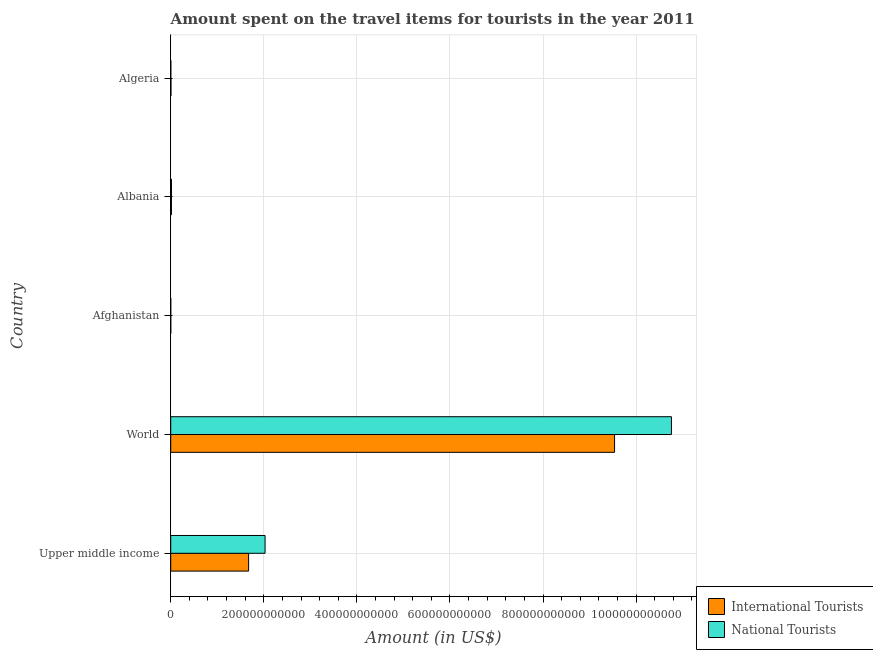How many different coloured bars are there?
Keep it short and to the point. 2. How many groups of bars are there?
Provide a short and direct response. 5. What is the label of the 3rd group of bars from the top?
Provide a succinct answer. Afghanistan. What is the amount spent on travel items of international tourists in Algeria?
Ensure brevity in your answer.  5.02e+08. Across all countries, what is the maximum amount spent on travel items of international tourists?
Provide a short and direct response. 9.54e+11. Across all countries, what is the minimum amount spent on travel items of international tourists?
Your answer should be compact. 1.13e+08. In which country was the amount spent on travel items of international tourists maximum?
Keep it short and to the point. World. In which country was the amount spent on travel items of international tourists minimum?
Give a very brief answer. Afghanistan. What is the total amount spent on travel items of national tourists in the graph?
Your response must be concise. 1.28e+12. What is the difference between the amount spent on travel items of national tourists in Upper middle income and that in World?
Your answer should be compact. -8.73e+11. What is the difference between the amount spent on travel items of international tourists in Upper middle income and the amount spent on travel items of national tourists in Afghanistan?
Make the answer very short. 1.67e+11. What is the average amount spent on travel items of national tourists per country?
Offer a terse response. 2.56e+11. What is the difference between the amount spent on travel items of national tourists and amount spent on travel items of international tourists in Afghanistan?
Offer a terse response. -4.20e+07. What is the ratio of the amount spent on travel items of national tourists in Upper middle income to that in World?
Provide a short and direct response. 0.19. What is the difference between the highest and the second highest amount spent on travel items of international tourists?
Make the answer very short. 7.86e+11. What is the difference between the highest and the lowest amount spent on travel items of national tourists?
Keep it short and to the point. 1.08e+12. Is the sum of the amount spent on travel items of national tourists in Afghanistan and World greater than the maximum amount spent on travel items of international tourists across all countries?
Provide a short and direct response. Yes. What does the 1st bar from the top in Albania represents?
Keep it short and to the point. National Tourists. What does the 1st bar from the bottom in Afghanistan represents?
Keep it short and to the point. International Tourists. How many bars are there?
Offer a very short reply. 10. What is the difference between two consecutive major ticks on the X-axis?
Offer a very short reply. 2.00e+11. Are the values on the major ticks of X-axis written in scientific E-notation?
Your answer should be compact. No. Does the graph contain grids?
Keep it short and to the point. Yes. How many legend labels are there?
Give a very brief answer. 2. How are the legend labels stacked?
Offer a very short reply. Vertical. What is the title of the graph?
Offer a very short reply. Amount spent on the travel items for tourists in the year 2011. What is the label or title of the Y-axis?
Provide a short and direct response. Country. What is the Amount (in US$) of International Tourists in Upper middle income?
Your response must be concise. 1.67e+11. What is the Amount (in US$) in National Tourists in Upper middle income?
Offer a terse response. 2.03e+11. What is the Amount (in US$) in International Tourists in World?
Make the answer very short. 9.54e+11. What is the Amount (in US$) of National Tourists in World?
Provide a succinct answer. 1.08e+12. What is the Amount (in US$) of International Tourists in Afghanistan?
Your response must be concise. 1.13e+08. What is the Amount (in US$) in National Tourists in Afghanistan?
Keep it short and to the point. 7.10e+07. What is the Amount (in US$) in International Tourists in Albania?
Make the answer very short. 1.56e+09. What is the Amount (in US$) of National Tourists in Albania?
Give a very brief answer. 1.63e+09. What is the Amount (in US$) of International Tourists in Algeria?
Offer a very short reply. 5.02e+08. What is the Amount (in US$) in National Tourists in Algeria?
Offer a very short reply. 2.09e+08. Across all countries, what is the maximum Amount (in US$) in International Tourists?
Make the answer very short. 9.54e+11. Across all countries, what is the maximum Amount (in US$) of National Tourists?
Your response must be concise. 1.08e+12. Across all countries, what is the minimum Amount (in US$) of International Tourists?
Offer a very short reply. 1.13e+08. Across all countries, what is the minimum Amount (in US$) of National Tourists?
Provide a succinct answer. 7.10e+07. What is the total Amount (in US$) in International Tourists in the graph?
Your response must be concise. 1.12e+12. What is the total Amount (in US$) of National Tourists in the graph?
Make the answer very short. 1.28e+12. What is the difference between the Amount (in US$) of International Tourists in Upper middle income and that in World?
Offer a terse response. -7.86e+11. What is the difference between the Amount (in US$) in National Tourists in Upper middle income and that in World?
Provide a succinct answer. -8.73e+11. What is the difference between the Amount (in US$) in International Tourists in Upper middle income and that in Afghanistan?
Offer a terse response. 1.67e+11. What is the difference between the Amount (in US$) in National Tourists in Upper middle income and that in Afghanistan?
Your answer should be compact. 2.03e+11. What is the difference between the Amount (in US$) of International Tourists in Upper middle income and that in Albania?
Your answer should be very brief. 1.66e+11. What is the difference between the Amount (in US$) in National Tourists in Upper middle income and that in Albania?
Your answer should be compact. 2.01e+11. What is the difference between the Amount (in US$) in International Tourists in Upper middle income and that in Algeria?
Offer a very short reply. 1.67e+11. What is the difference between the Amount (in US$) in National Tourists in Upper middle income and that in Algeria?
Make the answer very short. 2.03e+11. What is the difference between the Amount (in US$) of International Tourists in World and that in Afghanistan?
Your answer should be compact. 9.54e+11. What is the difference between the Amount (in US$) of National Tourists in World and that in Afghanistan?
Keep it short and to the point. 1.08e+12. What is the difference between the Amount (in US$) of International Tourists in World and that in Albania?
Offer a terse response. 9.52e+11. What is the difference between the Amount (in US$) of National Tourists in World and that in Albania?
Provide a succinct answer. 1.07e+12. What is the difference between the Amount (in US$) of International Tourists in World and that in Algeria?
Provide a short and direct response. 9.53e+11. What is the difference between the Amount (in US$) of National Tourists in World and that in Algeria?
Your answer should be compact. 1.08e+12. What is the difference between the Amount (in US$) of International Tourists in Afghanistan and that in Albania?
Offer a terse response. -1.45e+09. What is the difference between the Amount (in US$) in National Tourists in Afghanistan and that in Albania?
Your response must be concise. -1.56e+09. What is the difference between the Amount (in US$) in International Tourists in Afghanistan and that in Algeria?
Provide a short and direct response. -3.89e+08. What is the difference between the Amount (in US$) in National Tourists in Afghanistan and that in Algeria?
Offer a very short reply. -1.38e+08. What is the difference between the Amount (in US$) of International Tourists in Albania and that in Algeria?
Give a very brief answer. 1.06e+09. What is the difference between the Amount (in US$) of National Tourists in Albania and that in Algeria?
Your answer should be compact. 1.42e+09. What is the difference between the Amount (in US$) in International Tourists in Upper middle income and the Amount (in US$) in National Tourists in World?
Ensure brevity in your answer.  -9.08e+11. What is the difference between the Amount (in US$) in International Tourists in Upper middle income and the Amount (in US$) in National Tourists in Afghanistan?
Your answer should be compact. 1.67e+11. What is the difference between the Amount (in US$) of International Tourists in Upper middle income and the Amount (in US$) of National Tourists in Albania?
Keep it short and to the point. 1.66e+11. What is the difference between the Amount (in US$) of International Tourists in Upper middle income and the Amount (in US$) of National Tourists in Algeria?
Keep it short and to the point. 1.67e+11. What is the difference between the Amount (in US$) of International Tourists in World and the Amount (in US$) of National Tourists in Afghanistan?
Offer a terse response. 9.54e+11. What is the difference between the Amount (in US$) of International Tourists in World and the Amount (in US$) of National Tourists in Albania?
Keep it short and to the point. 9.52e+11. What is the difference between the Amount (in US$) of International Tourists in World and the Amount (in US$) of National Tourists in Algeria?
Keep it short and to the point. 9.53e+11. What is the difference between the Amount (in US$) in International Tourists in Afghanistan and the Amount (in US$) in National Tourists in Albania?
Provide a succinct answer. -1.52e+09. What is the difference between the Amount (in US$) in International Tourists in Afghanistan and the Amount (in US$) in National Tourists in Algeria?
Ensure brevity in your answer.  -9.60e+07. What is the difference between the Amount (in US$) in International Tourists in Albania and the Amount (in US$) in National Tourists in Algeria?
Your response must be concise. 1.36e+09. What is the average Amount (in US$) of International Tourists per country?
Provide a short and direct response. 2.25e+11. What is the average Amount (in US$) in National Tourists per country?
Provide a succinct answer. 2.56e+11. What is the difference between the Amount (in US$) of International Tourists and Amount (in US$) of National Tourists in Upper middle income?
Ensure brevity in your answer.  -3.54e+1. What is the difference between the Amount (in US$) of International Tourists and Amount (in US$) of National Tourists in World?
Your answer should be compact. -1.22e+11. What is the difference between the Amount (in US$) of International Tourists and Amount (in US$) of National Tourists in Afghanistan?
Your answer should be compact. 4.20e+07. What is the difference between the Amount (in US$) in International Tourists and Amount (in US$) in National Tourists in Albania?
Make the answer very short. -6.70e+07. What is the difference between the Amount (in US$) in International Tourists and Amount (in US$) in National Tourists in Algeria?
Provide a succinct answer. 2.93e+08. What is the ratio of the Amount (in US$) in International Tourists in Upper middle income to that in World?
Offer a terse response. 0.18. What is the ratio of the Amount (in US$) of National Tourists in Upper middle income to that in World?
Ensure brevity in your answer.  0.19. What is the ratio of the Amount (in US$) of International Tourists in Upper middle income to that in Afghanistan?
Offer a terse response. 1481.08. What is the ratio of the Amount (in US$) of National Tourists in Upper middle income to that in Afghanistan?
Ensure brevity in your answer.  2855.6. What is the ratio of the Amount (in US$) in International Tourists in Upper middle income to that in Albania?
Make the answer very short. 106.94. What is the ratio of the Amount (in US$) of National Tourists in Upper middle income to that in Albania?
Keep it short and to the point. 124.23. What is the ratio of the Amount (in US$) in International Tourists in Upper middle income to that in Algeria?
Provide a succinct answer. 333.39. What is the ratio of the Amount (in US$) of National Tourists in Upper middle income to that in Algeria?
Your answer should be very brief. 970.08. What is the ratio of the Amount (in US$) of International Tourists in World to that in Afghanistan?
Provide a short and direct response. 8439.31. What is the ratio of the Amount (in US$) of National Tourists in World to that in Afghanistan?
Your answer should be very brief. 1.52e+04. What is the ratio of the Amount (in US$) of International Tourists in World to that in Albania?
Make the answer very short. 609.36. What is the ratio of the Amount (in US$) in National Tourists in World to that in Albania?
Offer a very short reply. 659.22. What is the ratio of the Amount (in US$) of International Tourists in World to that in Algeria?
Make the answer very short. 1899.69. What is the ratio of the Amount (in US$) in National Tourists in World to that in Algeria?
Ensure brevity in your answer.  5147.58. What is the ratio of the Amount (in US$) of International Tourists in Afghanistan to that in Albania?
Give a very brief answer. 0.07. What is the ratio of the Amount (in US$) in National Tourists in Afghanistan to that in Albania?
Your answer should be compact. 0.04. What is the ratio of the Amount (in US$) of International Tourists in Afghanistan to that in Algeria?
Your answer should be compact. 0.23. What is the ratio of the Amount (in US$) in National Tourists in Afghanistan to that in Algeria?
Your answer should be compact. 0.34. What is the ratio of the Amount (in US$) in International Tourists in Albania to that in Algeria?
Make the answer very short. 3.12. What is the ratio of the Amount (in US$) of National Tourists in Albania to that in Algeria?
Your answer should be compact. 7.81. What is the difference between the highest and the second highest Amount (in US$) in International Tourists?
Ensure brevity in your answer.  7.86e+11. What is the difference between the highest and the second highest Amount (in US$) in National Tourists?
Keep it short and to the point. 8.73e+11. What is the difference between the highest and the lowest Amount (in US$) in International Tourists?
Offer a very short reply. 9.54e+11. What is the difference between the highest and the lowest Amount (in US$) in National Tourists?
Your response must be concise. 1.08e+12. 